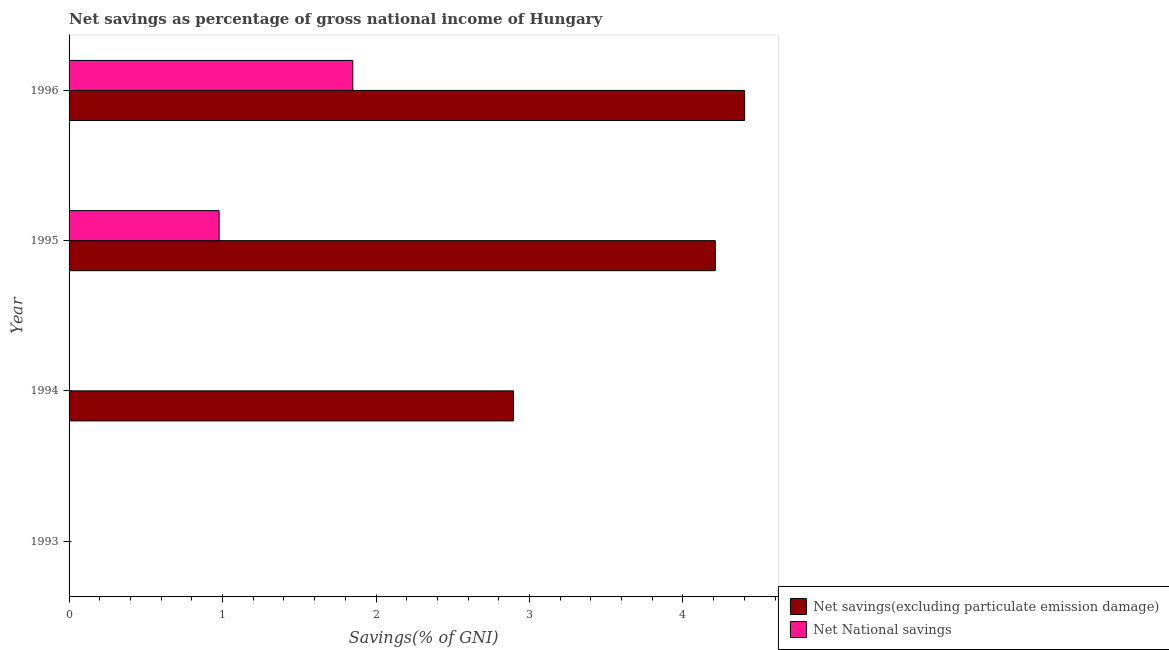Are the number of bars per tick equal to the number of legend labels?
Your response must be concise. No. Are the number of bars on each tick of the Y-axis equal?
Provide a short and direct response. No. How many bars are there on the 4th tick from the top?
Ensure brevity in your answer.  0. How many bars are there on the 1st tick from the bottom?
Your answer should be compact. 0. What is the label of the 2nd group of bars from the top?
Provide a short and direct response. 1995. What is the net savings(excluding particulate emission damage) in 1996?
Your response must be concise. 4.4. Across all years, what is the maximum net national savings?
Your answer should be compact. 1.85. Across all years, what is the minimum net national savings?
Offer a very short reply. 0. What is the total net national savings in the graph?
Offer a terse response. 2.83. What is the difference between the net savings(excluding particulate emission damage) in 1994 and that in 1995?
Your response must be concise. -1.31. What is the difference between the net national savings in 1995 and the net savings(excluding particulate emission damage) in 1993?
Offer a terse response. 0.98. What is the average net national savings per year?
Give a very brief answer. 0.71. In the year 1996, what is the difference between the net savings(excluding particulate emission damage) and net national savings?
Give a very brief answer. 2.55. In how many years, is the net savings(excluding particulate emission damage) greater than 0.2 %?
Keep it short and to the point. 3. What is the ratio of the net national savings in 1995 to that in 1996?
Keep it short and to the point. 0.53. What is the difference between the highest and the second highest net savings(excluding particulate emission damage)?
Your answer should be very brief. 0.19. What is the difference between the highest and the lowest net national savings?
Your answer should be very brief. 1.85. In how many years, is the net national savings greater than the average net national savings taken over all years?
Provide a short and direct response. 2. Is the sum of the net savings(excluding particulate emission damage) in 1994 and 1995 greater than the maximum net national savings across all years?
Provide a short and direct response. Yes. Does the graph contain any zero values?
Your answer should be very brief. Yes. How are the legend labels stacked?
Your response must be concise. Vertical. What is the title of the graph?
Your response must be concise. Net savings as percentage of gross national income of Hungary. Does "Secondary Education" appear as one of the legend labels in the graph?
Provide a short and direct response. No. What is the label or title of the X-axis?
Ensure brevity in your answer.  Savings(% of GNI). What is the Savings(% of GNI) in Net savings(excluding particulate emission damage) in 1994?
Provide a short and direct response. 2.9. What is the Savings(% of GNI) of Net National savings in 1994?
Keep it short and to the point. 0. What is the Savings(% of GNI) in Net savings(excluding particulate emission damage) in 1995?
Keep it short and to the point. 4.21. What is the Savings(% of GNI) of Net National savings in 1995?
Give a very brief answer. 0.98. What is the Savings(% of GNI) of Net savings(excluding particulate emission damage) in 1996?
Give a very brief answer. 4.4. What is the Savings(% of GNI) of Net National savings in 1996?
Make the answer very short. 1.85. Across all years, what is the maximum Savings(% of GNI) of Net savings(excluding particulate emission damage)?
Provide a succinct answer. 4.4. Across all years, what is the maximum Savings(% of GNI) of Net National savings?
Your answer should be compact. 1.85. Across all years, what is the minimum Savings(% of GNI) in Net National savings?
Offer a very short reply. 0. What is the total Savings(% of GNI) of Net savings(excluding particulate emission damage) in the graph?
Give a very brief answer. 11.51. What is the total Savings(% of GNI) of Net National savings in the graph?
Provide a short and direct response. 2.83. What is the difference between the Savings(% of GNI) in Net savings(excluding particulate emission damage) in 1994 and that in 1995?
Provide a short and direct response. -1.32. What is the difference between the Savings(% of GNI) in Net savings(excluding particulate emission damage) in 1994 and that in 1996?
Offer a terse response. -1.51. What is the difference between the Savings(% of GNI) of Net savings(excluding particulate emission damage) in 1995 and that in 1996?
Offer a very short reply. -0.19. What is the difference between the Savings(% of GNI) of Net National savings in 1995 and that in 1996?
Make the answer very short. -0.87. What is the difference between the Savings(% of GNI) in Net savings(excluding particulate emission damage) in 1994 and the Savings(% of GNI) in Net National savings in 1995?
Your response must be concise. 1.92. What is the difference between the Savings(% of GNI) in Net savings(excluding particulate emission damage) in 1994 and the Savings(% of GNI) in Net National savings in 1996?
Offer a terse response. 1.05. What is the difference between the Savings(% of GNI) in Net savings(excluding particulate emission damage) in 1995 and the Savings(% of GNI) in Net National savings in 1996?
Your answer should be very brief. 2.36. What is the average Savings(% of GNI) of Net savings(excluding particulate emission damage) per year?
Offer a very short reply. 2.88. What is the average Savings(% of GNI) in Net National savings per year?
Your response must be concise. 0.71. In the year 1995, what is the difference between the Savings(% of GNI) of Net savings(excluding particulate emission damage) and Savings(% of GNI) of Net National savings?
Make the answer very short. 3.23. In the year 1996, what is the difference between the Savings(% of GNI) of Net savings(excluding particulate emission damage) and Savings(% of GNI) of Net National savings?
Your response must be concise. 2.55. What is the ratio of the Savings(% of GNI) in Net savings(excluding particulate emission damage) in 1994 to that in 1995?
Offer a very short reply. 0.69. What is the ratio of the Savings(% of GNI) of Net savings(excluding particulate emission damage) in 1994 to that in 1996?
Offer a very short reply. 0.66. What is the ratio of the Savings(% of GNI) of Net savings(excluding particulate emission damage) in 1995 to that in 1996?
Your answer should be compact. 0.96. What is the ratio of the Savings(% of GNI) in Net National savings in 1995 to that in 1996?
Offer a very short reply. 0.53. What is the difference between the highest and the second highest Savings(% of GNI) in Net savings(excluding particulate emission damage)?
Offer a terse response. 0.19. What is the difference between the highest and the lowest Savings(% of GNI) of Net savings(excluding particulate emission damage)?
Offer a terse response. 4.4. What is the difference between the highest and the lowest Savings(% of GNI) in Net National savings?
Your response must be concise. 1.85. 